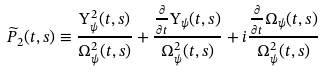<formula> <loc_0><loc_0><loc_500><loc_500>\widetilde { P } _ { 2 } ( t , s ) \equiv \frac { \Upsilon ^ { 2 } _ { \psi } ( t , s ) } { \Omega ^ { 2 } _ { \psi } ( t , s ) } + \frac { \frac { \partial } { \partial t } \Upsilon _ { \psi } ( t , s ) } { \Omega ^ { 2 } _ { \psi } ( t , s ) } + i \frac { \frac { \partial } { \partial t } \Omega _ { \psi } ( t , s ) } { \Omega ^ { 2 } _ { \psi } ( t , s ) }</formula> 